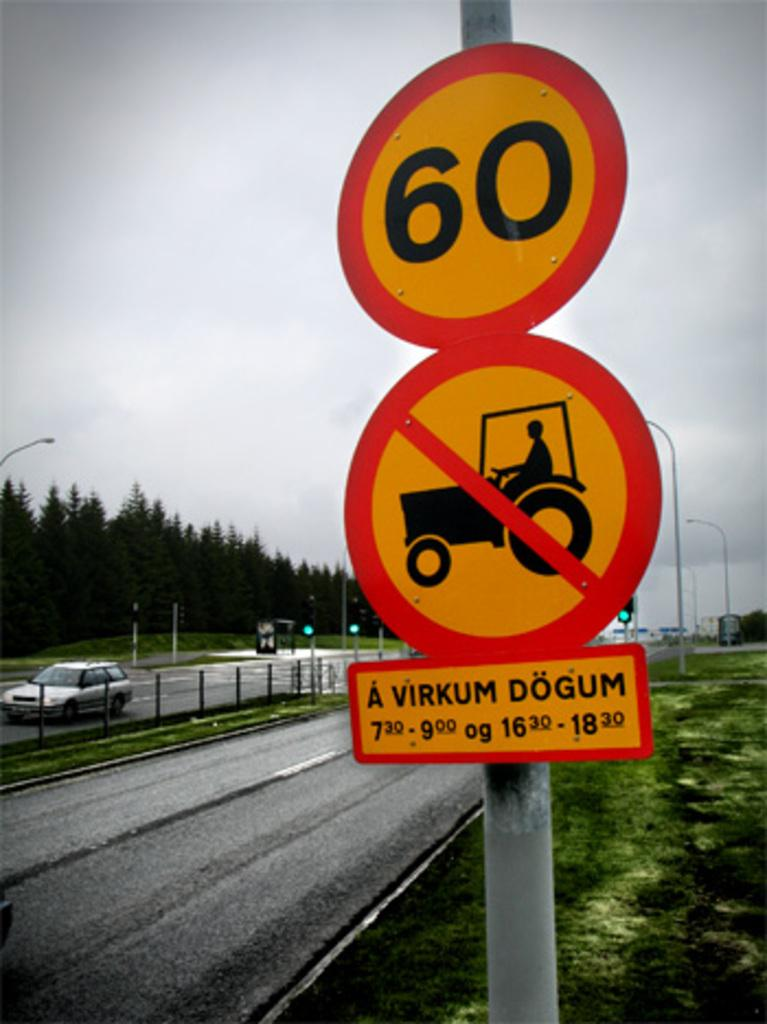<image>
Create a compact narrative representing the image presented. the number 60 that is on a sign 